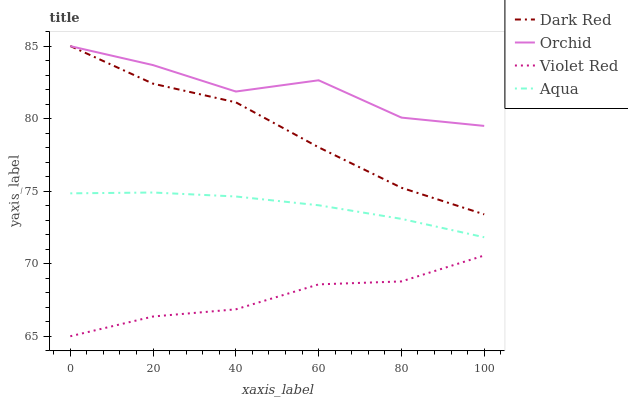Does Violet Red have the minimum area under the curve?
Answer yes or no. Yes. Does Orchid have the maximum area under the curve?
Answer yes or no. Yes. Does Aqua have the minimum area under the curve?
Answer yes or no. No. Does Aqua have the maximum area under the curve?
Answer yes or no. No. Is Aqua the smoothest?
Answer yes or no. Yes. Is Orchid the roughest?
Answer yes or no. Yes. Is Violet Red the smoothest?
Answer yes or no. No. Is Violet Red the roughest?
Answer yes or no. No. Does Violet Red have the lowest value?
Answer yes or no. Yes. Does Aqua have the lowest value?
Answer yes or no. No. Does Dark Red have the highest value?
Answer yes or no. Yes. Does Aqua have the highest value?
Answer yes or no. No. Is Aqua less than Dark Red?
Answer yes or no. Yes. Is Orchid greater than Violet Red?
Answer yes or no. Yes. Does Orchid intersect Dark Red?
Answer yes or no. Yes. Is Orchid less than Dark Red?
Answer yes or no. No. Is Orchid greater than Dark Red?
Answer yes or no. No. Does Aqua intersect Dark Red?
Answer yes or no. No. 